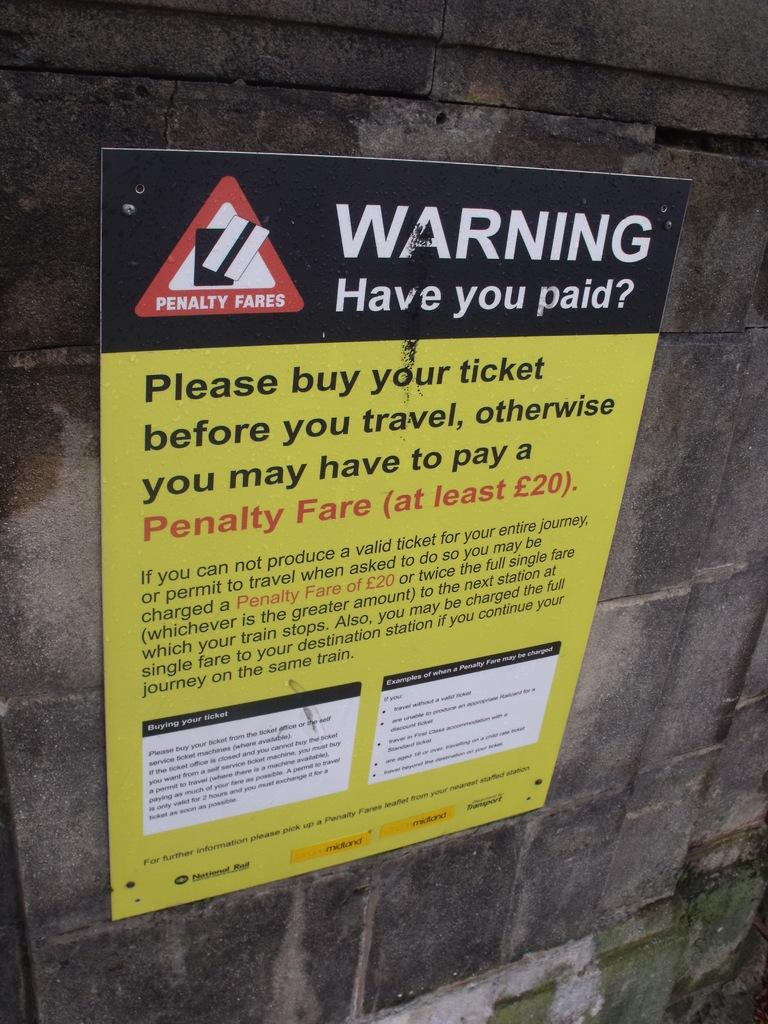<image>
Create a compact narrative representing the image presented. A yellow and black Sign that reads "warning have you paid?: on the top of it. 